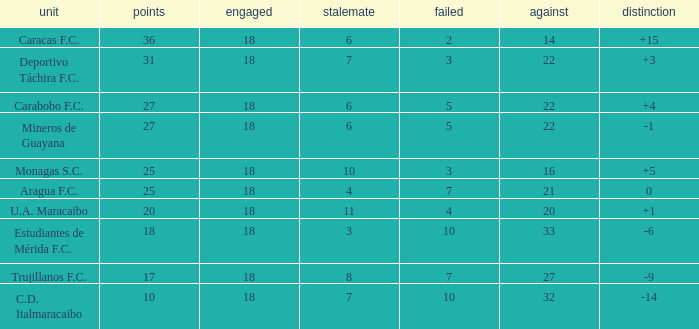What is the sum of the points of all teams that had against scores less than 14? None. 